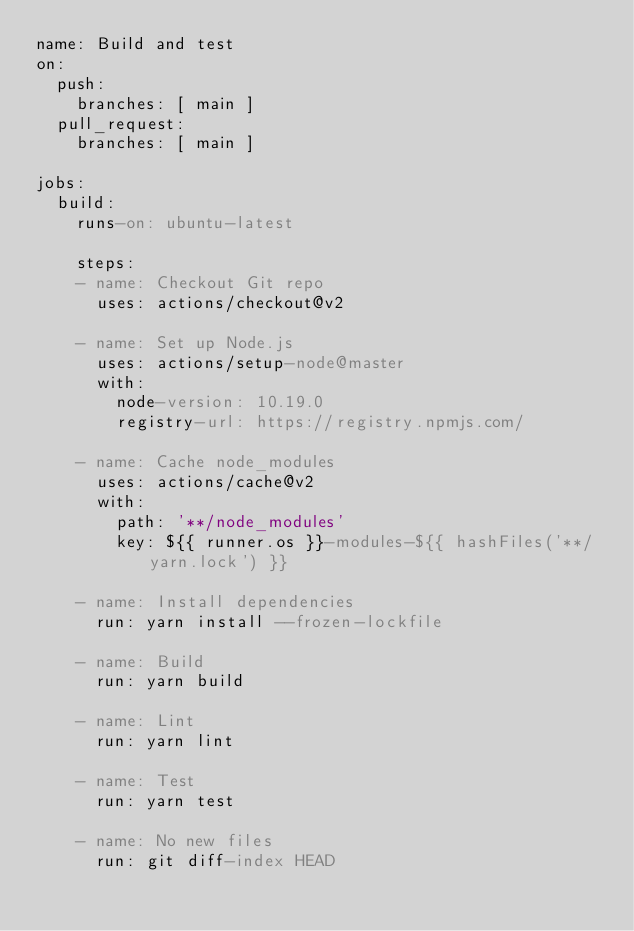<code> <loc_0><loc_0><loc_500><loc_500><_YAML_>name: Build and test
on:
  push:
    branches: [ main ]
  pull_request:
    branches: [ main ]

jobs:
  build:
    runs-on: ubuntu-latest

    steps:
    - name: Checkout Git repo
      uses: actions/checkout@v2

    - name: Set up Node.js
      uses: actions/setup-node@master
      with:
        node-version: 10.19.0
        registry-url: https://registry.npmjs.com/
    
    - name: Cache node_modules
      uses: actions/cache@v2
      with:
        path: '**/node_modules'
        key: ${{ runner.os }}-modules-${{ hashFiles('**/yarn.lock') }}
    
    - name: Install dependencies
      run: yarn install --frozen-lockfile
  
    - name: Build
      run: yarn build

    - name: Lint
      run: yarn lint
    
    - name: Test
      run: yarn test

    - name: No new files
      run: git diff-index HEAD 
</code> 